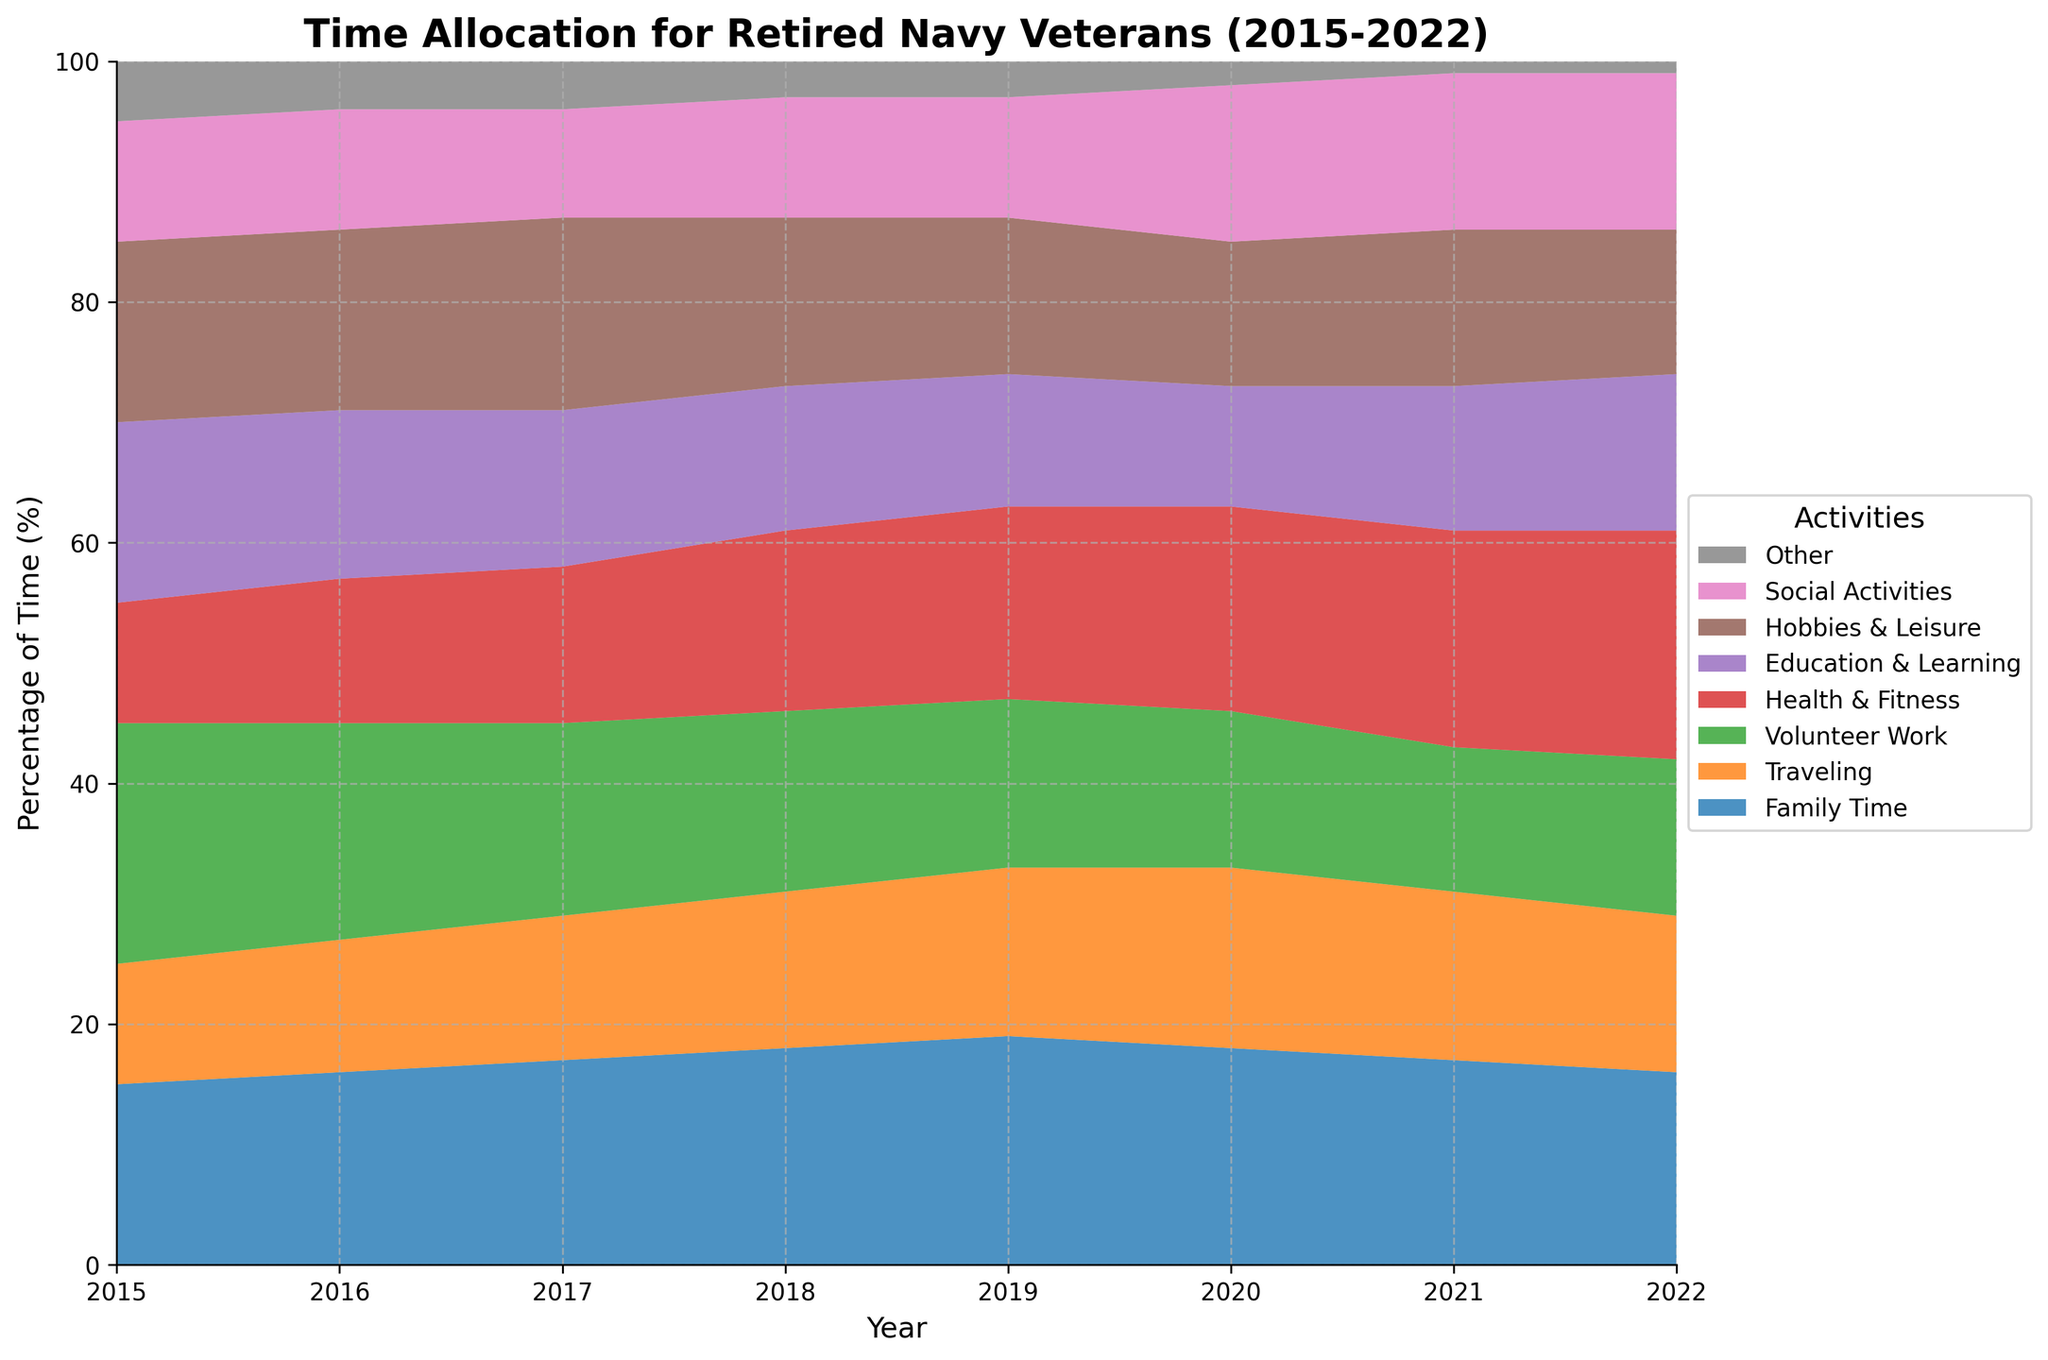What is the title of the chart? The title of the chart is typically found at the top and it provides a summary of what the chart represents. In this case, the title states, "Time Allocation for Retired Navy Veterans (2015-2022)."
Answer: Time Allocation for Retired Navy Veterans (2015-2022) Which activity had the highest percentage of time allocated in 2015? To answer this, look at the different areas on the chart for the year 2015 and determine which activity takes up the largest portion of the total. According to the chart, 'Volunteer Work' has the highest percentage in 2015.
Answer: Volunteer Work How did the percentage of time spent on 'Traveling' change from 2015 to 2022? Compare the portion of the area representing 'Traveling' between the two years 2015 and 2022. The chart shows that 'Traveling' increased from 10% in 2015 to 13% in 2022.
Answer: Increased by 3% Which year showed the highest allocation of time for 'Health & Fitness'? Look for the peak area of 'Health & Fitness' across the years. The chart indicates that 2022 had the highest allocation for 'Health & Fitness' at 19%.
Answer: 2022 In 2020, which two activities took up the smallest portions of time? Examine the proportions of areas in 2020 and identify the two smallest ones. According to the chart, 'Other' and 'Family Time' were the smallest, with 'Other' at 2% and 'Family Time' at 18%.
Answer: Other and Family Time What is the total percentage of time spent on 'Family Time' and 'Social Activities' in 2018? To find the total percentage, add the percentages of 'Family Time' (18%) and 'Social Activities' (10%) from the year 2018. So, 18% + 10% = 28%.
Answer: 28% Compare the percentage of time spent on 'Hobbies & Leisure' and 'Volunteer Work' in 2021. Which had a higher percentage? Look at the chart for the year 2021 and compare the two activities. The chart shows 'Volunteer Work' at 12% and 'Hobbies & Leisure' at 13%, meaning 'Hobbies & Leisure' had a higher percentage.
Answer: Hobbies & Leisure Which activity saw the most consistent percentage of time allocation from 2015 to 2022? To identify the most consistent activity, observe the areas for each activity across all years and assess their stability. 'Social Activities' appears to be the most consistent, ranging only between 9% to 13%.
Answer: Social Activities 